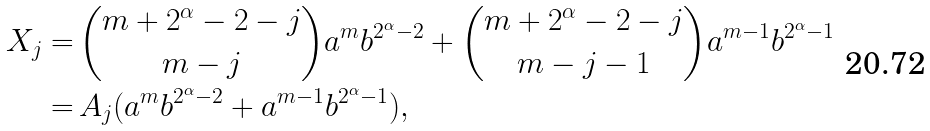Convert formula to latex. <formula><loc_0><loc_0><loc_500><loc_500>X _ { j } = & \, { m + 2 ^ { \alpha } - 2 - j \choose m - j } a ^ { m } b ^ { 2 ^ { \alpha } - 2 } + { m + 2 ^ { \alpha } - 2 - j \choose m - j - 1 } a ^ { m - 1 } b ^ { 2 ^ { \alpha } - 1 } \\ = & \, A _ { j } ( a ^ { m } b ^ { 2 ^ { \alpha } - 2 } + a ^ { m - 1 } b ^ { 2 ^ { \alpha } - 1 } ) ,</formula> 